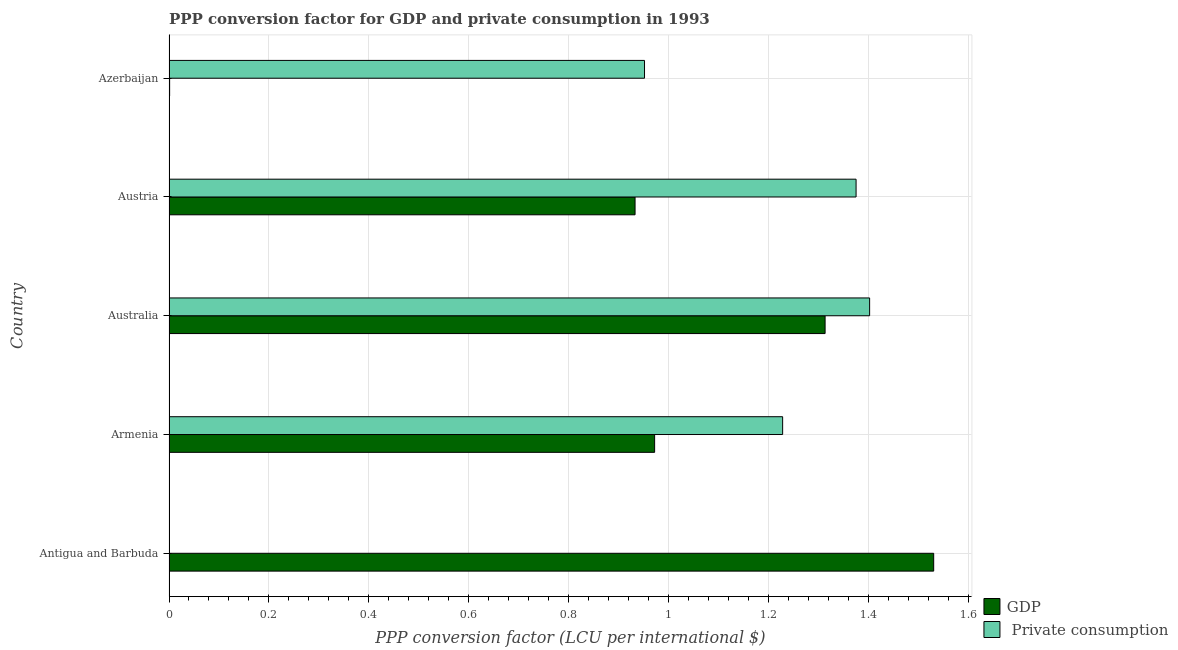Are the number of bars per tick equal to the number of legend labels?
Offer a terse response. Yes. Are the number of bars on each tick of the Y-axis equal?
Give a very brief answer. Yes. How many bars are there on the 5th tick from the top?
Make the answer very short. 2. How many bars are there on the 4th tick from the bottom?
Make the answer very short. 2. What is the label of the 4th group of bars from the top?
Provide a succinct answer. Armenia. What is the ppp conversion factor for gdp in Azerbaijan?
Your answer should be very brief. 0. Across all countries, what is the maximum ppp conversion factor for private consumption?
Your response must be concise. 1.4. Across all countries, what is the minimum ppp conversion factor for private consumption?
Keep it short and to the point. 2.43943568966772e-6. In which country was the ppp conversion factor for gdp maximum?
Offer a terse response. Antigua and Barbuda. In which country was the ppp conversion factor for gdp minimum?
Make the answer very short. Azerbaijan. What is the total ppp conversion factor for private consumption in the graph?
Your answer should be very brief. 4.96. What is the difference between the ppp conversion factor for private consumption in Antigua and Barbuda and that in Austria?
Keep it short and to the point. -1.38. What is the difference between the ppp conversion factor for gdp in Armenia and the ppp conversion factor for private consumption in Azerbaijan?
Ensure brevity in your answer.  0.02. What is the average ppp conversion factor for gdp per country?
Your answer should be very brief. 0.95. What is the difference between the ppp conversion factor for gdp and ppp conversion factor for private consumption in Azerbaijan?
Provide a short and direct response. -0.95. In how many countries, is the ppp conversion factor for gdp greater than 0.9600000000000001 LCU?
Ensure brevity in your answer.  3. What is the difference between the highest and the second highest ppp conversion factor for gdp?
Offer a very short reply. 0.22. What is the difference between the highest and the lowest ppp conversion factor for gdp?
Offer a terse response. 1.53. In how many countries, is the ppp conversion factor for private consumption greater than the average ppp conversion factor for private consumption taken over all countries?
Your response must be concise. 3. What does the 2nd bar from the top in Austria represents?
Offer a very short reply. GDP. What does the 2nd bar from the bottom in Antigua and Barbuda represents?
Ensure brevity in your answer.   Private consumption. How many bars are there?
Give a very brief answer. 10. What is the difference between two consecutive major ticks on the X-axis?
Offer a very short reply. 0.2. Does the graph contain any zero values?
Provide a succinct answer. No. Does the graph contain grids?
Your response must be concise. Yes. Where does the legend appear in the graph?
Offer a very short reply. Bottom right. What is the title of the graph?
Provide a succinct answer. PPP conversion factor for GDP and private consumption in 1993. Does "Secondary Education" appear as one of the legend labels in the graph?
Your answer should be compact. No. What is the label or title of the X-axis?
Offer a very short reply. PPP conversion factor (LCU per international $). What is the PPP conversion factor (LCU per international $) of GDP in Antigua and Barbuda?
Offer a terse response. 1.53. What is the PPP conversion factor (LCU per international $) in  Private consumption in Antigua and Barbuda?
Offer a terse response. 2.43943568966772e-6. What is the PPP conversion factor (LCU per international $) of GDP in Armenia?
Ensure brevity in your answer.  0.97. What is the PPP conversion factor (LCU per international $) of  Private consumption in Armenia?
Provide a succinct answer. 1.23. What is the PPP conversion factor (LCU per international $) in GDP in Australia?
Make the answer very short. 1.31. What is the PPP conversion factor (LCU per international $) of  Private consumption in Australia?
Keep it short and to the point. 1.4. What is the PPP conversion factor (LCU per international $) of GDP in Austria?
Give a very brief answer. 0.93. What is the PPP conversion factor (LCU per international $) in  Private consumption in Austria?
Make the answer very short. 1.38. What is the PPP conversion factor (LCU per international $) in GDP in Azerbaijan?
Offer a very short reply. 0. What is the PPP conversion factor (LCU per international $) in  Private consumption in Azerbaijan?
Ensure brevity in your answer.  0.95. Across all countries, what is the maximum PPP conversion factor (LCU per international $) of GDP?
Your response must be concise. 1.53. Across all countries, what is the maximum PPP conversion factor (LCU per international $) of  Private consumption?
Keep it short and to the point. 1.4. Across all countries, what is the minimum PPP conversion factor (LCU per international $) in GDP?
Ensure brevity in your answer.  0. Across all countries, what is the minimum PPP conversion factor (LCU per international $) in  Private consumption?
Give a very brief answer. 2.43943568966772e-6. What is the total PPP conversion factor (LCU per international $) in GDP in the graph?
Your answer should be compact. 4.75. What is the total PPP conversion factor (LCU per international $) of  Private consumption in the graph?
Ensure brevity in your answer.  4.96. What is the difference between the PPP conversion factor (LCU per international $) of GDP in Antigua and Barbuda and that in Armenia?
Provide a succinct answer. 0.56. What is the difference between the PPP conversion factor (LCU per international $) of  Private consumption in Antigua and Barbuda and that in Armenia?
Make the answer very short. -1.23. What is the difference between the PPP conversion factor (LCU per international $) of GDP in Antigua and Barbuda and that in Australia?
Provide a succinct answer. 0.22. What is the difference between the PPP conversion factor (LCU per international $) in  Private consumption in Antigua and Barbuda and that in Australia?
Your response must be concise. -1.4. What is the difference between the PPP conversion factor (LCU per international $) in GDP in Antigua and Barbuda and that in Austria?
Your answer should be compact. 0.6. What is the difference between the PPP conversion factor (LCU per international $) of  Private consumption in Antigua and Barbuda and that in Austria?
Offer a very short reply. -1.38. What is the difference between the PPP conversion factor (LCU per international $) of GDP in Antigua and Barbuda and that in Azerbaijan?
Keep it short and to the point. 1.53. What is the difference between the PPP conversion factor (LCU per international $) in  Private consumption in Antigua and Barbuda and that in Azerbaijan?
Provide a short and direct response. -0.95. What is the difference between the PPP conversion factor (LCU per international $) of GDP in Armenia and that in Australia?
Your answer should be compact. -0.34. What is the difference between the PPP conversion factor (LCU per international $) of  Private consumption in Armenia and that in Australia?
Offer a very short reply. -0.17. What is the difference between the PPP conversion factor (LCU per international $) of GDP in Armenia and that in Austria?
Give a very brief answer. 0.04. What is the difference between the PPP conversion factor (LCU per international $) of  Private consumption in Armenia and that in Austria?
Offer a very short reply. -0.15. What is the difference between the PPP conversion factor (LCU per international $) of GDP in Armenia and that in Azerbaijan?
Give a very brief answer. 0.97. What is the difference between the PPP conversion factor (LCU per international $) in  Private consumption in Armenia and that in Azerbaijan?
Your response must be concise. 0.28. What is the difference between the PPP conversion factor (LCU per international $) of GDP in Australia and that in Austria?
Offer a terse response. 0.38. What is the difference between the PPP conversion factor (LCU per international $) in  Private consumption in Australia and that in Austria?
Make the answer very short. 0.03. What is the difference between the PPP conversion factor (LCU per international $) of GDP in Australia and that in Azerbaijan?
Provide a short and direct response. 1.31. What is the difference between the PPP conversion factor (LCU per international $) in  Private consumption in Australia and that in Azerbaijan?
Ensure brevity in your answer.  0.45. What is the difference between the PPP conversion factor (LCU per international $) in GDP in Austria and that in Azerbaijan?
Give a very brief answer. 0.93. What is the difference between the PPP conversion factor (LCU per international $) in  Private consumption in Austria and that in Azerbaijan?
Your answer should be very brief. 0.42. What is the difference between the PPP conversion factor (LCU per international $) in GDP in Antigua and Barbuda and the PPP conversion factor (LCU per international $) in  Private consumption in Armenia?
Your answer should be very brief. 0.3. What is the difference between the PPP conversion factor (LCU per international $) of GDP in Antigua and Barbuda and the PPP conversion factor (LCU per international $) of  Private consumption in Australia?
Offer a terse response. 0.13. What is the difference between the PPP conversion factor (LCU per international $) of GDP in Antigua and Barbuda and the PPP conversion factor (LCU per international $) of  Private consumption in Austria?
Offer a terse response. 0.16. What is the difference between the PPP conversion factor (LCU per international $) in GDP in Antigua and Barbuda and the PPP conversion factor (LCU per international $) in  Private consumption in Azerbaijan?
Your answer should be very brief. 0.58. What is the difference between the PPP conversion factor (LCU per international $) of GDP in Armenia and the PPP conversion factor (LCU per international $) of  Private consumption in Australia?
Provide a short and direct response. -0.43. What is the difference between the PPP conversion factor (LCU per international $) in GDP in Armenia and the PPP conversion factor (LCU per international $) in  Private consumption in Austria?
Provide a succinct answer. -0.4. What is the difference between the PPP conversion factor (LCU per international $) in GDP in Armenia and the PPP conversion factor (LCU per international $) in  Private consumption in Azerbaijan?
Provide a short and direct response. 0.02. What is the difference between the PPP conversion factor (LCU per international $) in GDP in Australia and the PPP conversion factor (LCU per international $) in  Private consumption in Austria?
Give a very brief answer. -0.06. What is the difference between the PPP conversion factor (LCU per international $) of GDP in Australia and the PPP conversion factor (LCU per international $) of  Private consumption in Azerbaijan?
Your answer should be very brief. 0.36. What is the difference between the PPP conversion factor (LCU per international $) of GDP in Austria and the PPP conversion factor (LCU per international $) of  Private consumption in Azerbaijan?
Ensure brevity in your answer.  -0.02. What is the average PPP conversion factor (LCU per international $) of  Private consumption per country?
Keep it short and to the point. 0.99. What is the difference between the PPP conversion factor (LCU per international $) of GDP and PPP conversion factor (LCU per international $) of  Private consumption in Antigua and Barbuda?
Your answer should be compact. 1.53. What is the difference between the PPP conversion factor (LCU per international $) of GDP and PPP conversion factor (LCU per international $) of  Private consumption in Armenia?
Your answer should be very brief. -0.26. What is the difference between the PPP conversion factor (LCU per international $) of GDP and PPP conversion factor (LCU per international $) of  Private consumption in Australia?
Offer a very short reply. -0.09. What is the difference between the PPP conversion factor (LCU per international $) in GDP and PPP conversion factor (LCU per international $) in  Private consumption in Austria?
Offer a very short reply. -0.44. What is the difference between the PPP conversion factor (LCU per international $) of GDP and PPP conversion factor (LCU per international $) of  Private consumption in Azerbaijan?
Keep it short and to the point. -0.95. What is the ratio of the PPP conversion factor (LCU per international $) of GDP in Antigua and Barbuda to that in Armenia?
Your response must be concise. 1.57. What is the ratio of the PPP conversion factor (LCU per international $) in GDP in Antigua and Barbuda to that in Australia?
Offer a very short reply. 1.17. What is the ratio of the PPP conversion factor (LCU per international $) of GDP in Antigua and Barbuda to that in Austria?
Ensure brevity in your answer.  1.64. What is the ratio of the PPP conversion factor (LCU per international $) of GDP in Antigua and Barbuda to that in Azerbaijan?
Give a very brief answer. 1227.26. What is the ratio of the PPP conversion factor (LCU per international $) of GDP in Armenia to that in Australia?
Offer a terse response. 0.74. What is the ratio of the PPP conversion factor (LCU per international $) in  Private consumption in Armenia to that in Australia?
Your answer should be very brief. 0.88. What is the ratio of the PPP conversion factor (LCU per international $) of GDP in Armenia to that in Austria?
Your answer should be compact. 1.04. What is the ratio of the PPP conversion factor (LCU per international $) in  Private consumption in Armenia to that in Austria?
Ensure brevity in your answer.  0.89. What is the ratio of the PPP conversion factor (LCU per international $) of GDP in Armenia to that in Azerbaijan?
Provide a succinct answer. 779.38. What is the ratio of the PPP conversion factor (LCU per international $) of  Private consumption in Armenia to that in Azerbaijan?
Your answer should be very brief. 1.29. What is the ratio of the PPP conversion factor (LCU per international $) in GDP in Australia to that in Austria?
Provide a succinct answer. 1.41. What is the ratio of the PPP conversion factor (LCU per international $) in  Private consumption in Australia to that in Austria?
Your answer should be very brief. 1.02. What is the ratio of the PPP conversion factor (LCU per international $) of GDP in Australia to that in Azerbaijan?
Give a very brief answer. 1052.97. What is the ratio of the PPP conversion factor (LCU per international $) of  Private consumption in Australia to that in Azerbaijan?
Provide a succinct answer. 1.47. What is the ratio of the PPP conversion factor (LCU per international $) in GDP in Austria to that in Azerbaijan?
Your answer should be compact. 747.98. What is the ratio of the PPP conversion factor (LCU per international $) in  Private consumption in Austria to that in Azerbaijan?
Keep it short and to the point. 1.44. What is the difference between the highest and the second highest PPP conversion factor (LCU per international $) in GDP?
Your answer should be very brief. 0.22. What is the difference between the highest and the second highest PPP conversion factor (LCU per international $) of  Private consumption?
Your answer should be very brief. 0.03. What is the difference between the highest and the lowest PPP conversion factor (LCU per international $) in GDP?
Your answer should be compact. 1.53. What is the difference between the highest and the lowest PPP conversion factor (LCU per international $) in  Private consumption?
Offer a very short reply. 1.4. 